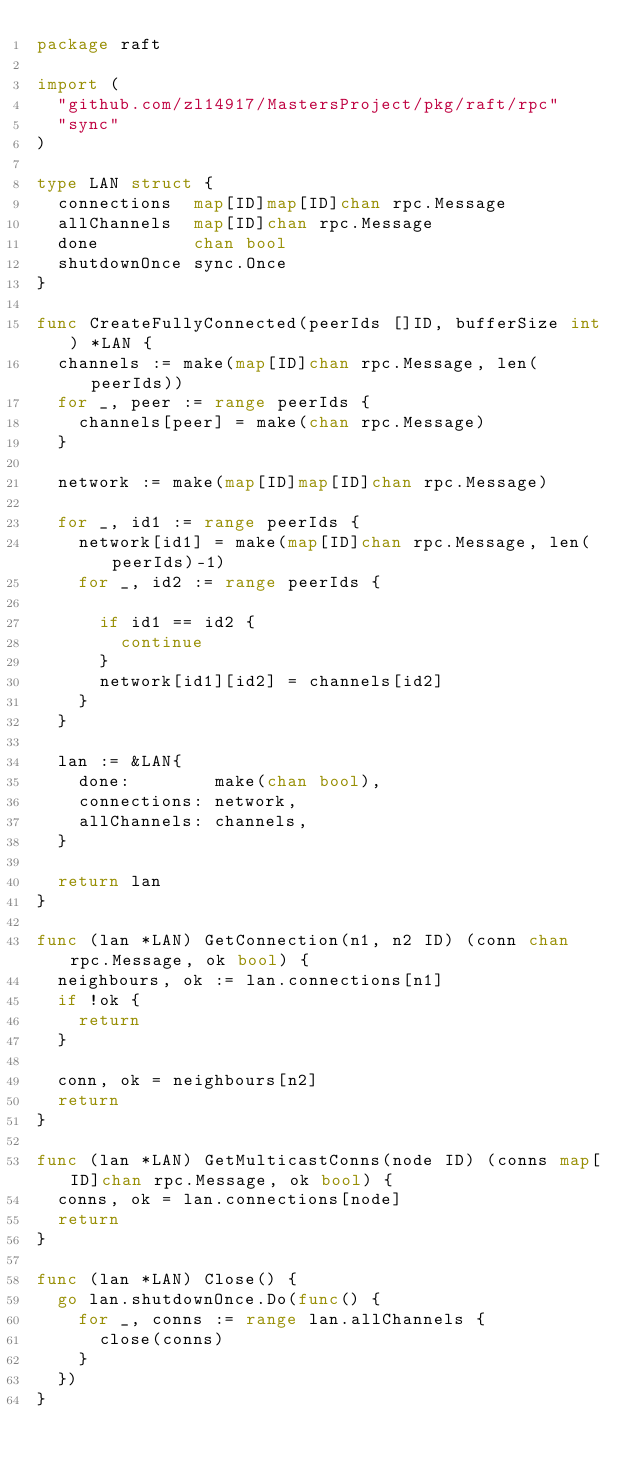Convert code to text. <code><loc_0><loc_0><loc_500><loc_500><_Go_>package raft

import (
	"github.com/zl14917/MastersProject/pkg/raft/rpc"
	"sync"
)

type LAN struct {
	connections  map[ID]map[ID]chan rpc.Message
	allChannels  map[ID]chan rpc.Message
	done         chan bool
	shutdownOnce sync.Once
}

func CreateFullyConnected(peerIds []ID, bufferSize int) *LAN {
	channels := make(map[ID]chan rpc.Message, len(peerIds))
	for _, peer := range peerIds {
		channels[peer] = make(chan rpc.Message)
	}

	network := make(map[ID]map[ID]chan rpc.Message)

	for _, id1 := range peerIds {
		network[id1] = make(map[ID]chan rpc.Message, len(peerIds)-1)
		for _, id2 := range peerIds {

			if id1 == id2 {
				continue
			}
			network[id1][id2] = channels[id2]
		}
	}

	lan := &LAN{
		done:        make(chan bool),
		connections: network,
		allChannels: channels,
	}

	return lan
}

func (lan *LAN) GetConnection(n1, n2 ID) (conn chan rpc.Message, ok bool) {
	neighbours, ok := lan.connections[n1]
	if !ok {
		return
	}

	conn, ok = neighbours[n2]
	return
}

func (lan *LAN) GetMulticastConns(node ID) (conns map[ID]chan rpc.Message, ok bool) {
	conns, ok = lan.connections[node]
	return
}

func (lan *LAN) Close() {
	go lan.shutdownOnce.Do(func() {
		for _, conns := range lan.allChannels {
			close(conns)
		}
	})
}
</code> 